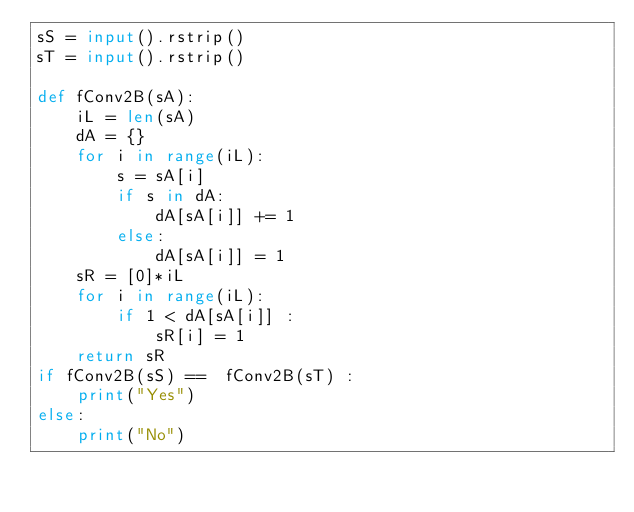Convert code to text. <code><loc_0><loc_0><loc_500><loc_500><_Python_>sS = input().rstrip()
sT = input().rstrip()

def fConv2B(sA):
    iL = len(sA)
    dA = {}
    for i in range(iL):
        s = sA[i]
        if s in dA:
            dA[sA[i]] += 1
        else:
            dA[sA[i]] = 1
    sR = [0]*iL
    for i in range(iL):
        if 1 < dA[sA[i]] :
            sR[i] = 1
    return sR
if fConv2B(sS) ==  fConv2B(sT) :
    print("Yes")
else:
    print("No")
</code> 